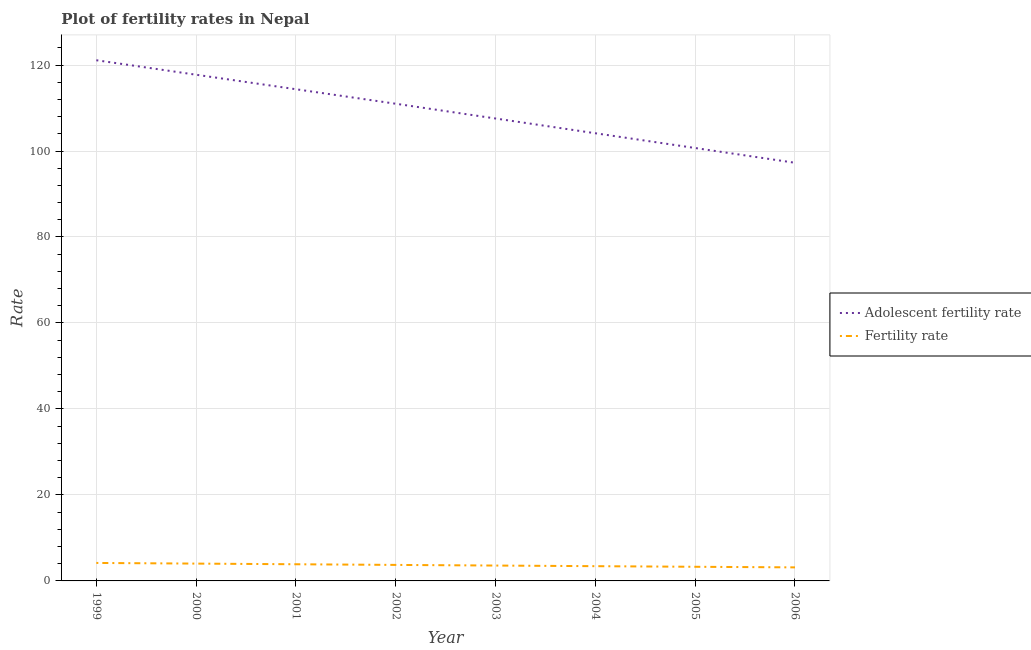How many different coloured lines are there?
Your response must be concise. 2. Is the number of lines equal to the number of legend labels?
Make the answer very short. Yes. What is the adolescent fertility rate in 2000?
Provide a succinct answer. 117.74. Across all years, what is the maximum fertility rate?
Provide a succinct answer. 4.18. Across all years, what is the minimum fertility rate?
Your answer should be very brief. 3.15. What is the total adolescent fertility rate in the graph?
Your response must be concise. 873.88. What is the difference between the fertility rate in 2002 and that in 2006?
Offer a very short reply. 0.57. What is the difference between the fertility rate in 2003 and the adolescent fertility rate in 2006?
Your answer should be very brief. -93.69. What is the average fertility rate per year?
Provide a short and direct response. 3.66. In the year 2001, what is the difference between the adolescent fertility rate and fertility rate?
Give a very brief answer. 110.49. What is the ratio of the adolescent fertility rate in 2003 to that in 2004?
Provide a succinct answer. 1.03. Is the difference between the adolescent fertility rate in 1999 and 2006 greater than the difference between the fertility rate in 1999 and 2006?
Give a very brief answer. Yes. What is the difference between the highest and the second highest adolescent fertility rate?
Offer a very short reply. 3.37. What is the difference between the highest and the lowest adolescent fertility rate?
Keep it short and to the point. 23.85. In how many years, is the adolescent fertility rate greater than the average adolescent fertility rate taken over all years?
Provide a short and direct response. 4. Is the sum of the fertility rate in 2002 and 2005 greater than the maximum adolescent fertility rate across all years?
Your answer should be compact. No. How many lines are there?
Your answer should be very brief. 2. Does the graph contain grids?
Your answer should be very brief. Yes. How many legend labels are there?
Provide a short and direct response. 2. What is the title of the graph?
Provide a succinct answer. Plot of fertility rates in Nepal. What is the label or title of the Y-axis?
Provide a short and direct response. Rate. What is the Rate of Adolescent fertility rate in 1999?
Offer a very short reply. 121.12. What is the Rate in Fertility rate in 1999?
Your answer should be very brief. 4.18. What is the Rate of Adolescent fertility rate in 2000?
Keep it short and to the point. 117.74. What is the Rate of Fertility rate in 2000?
Give a very brief answer. 4.03. What is the Rate of Adolescent fertility rate in 2001?
Ensure brevity in your answer.  114.37. What is the Rate of Fertility rate in 2001?
Offer a very short reply. 3.88. What is the Rate in Adolescent fertility rate in 2002?
Your answer should be very brief. 111. What is the Rate in Fertility rate in 2002?
Your answer should be compact. 3.72. What is the Rate of Adolescent fertility rate in 2003?
Ensure brevity in your answer.  107.56. What is the Rate in Fertility rate in 2003?
Ensure brevity in your answer.  3.58. What is the Rate of Adolescent fertility rate in 2004?
Provide a short and direct response. 104.13. What is the Rate in Fertility rate in 2004?
Offer a terse response. 3.43. What is the Rate in Adolescent fertility rate in 2005?
Provide a short and direct response. 100.7. What is the Rate in Fertility rate in 2005?
Your response must be concise. 3.29. What is the Rate of Adolescent fertility rate in 2006?
Offer a terse response. 97.26. What is the Rate in Fertility rate in 2006?
Offer a terse response. 3.15. Across all years, what is the maximum Rate in Adolescent fertility rate?
Offer a terse response. 121.12. Across all years, what is the maximum Rate of Fertility rate?
Give a very brief answer. 4.18. Across all years, what is the minimum Rate of Adolescent fertility rate?
Ensure brevity in your answer.  97.26. Across all years, what is the minimum Rate of Fertility rate?
Keep it short and to the point. 3.15. What is the total Rate of Adolescent fertility rate in the graph?
Give a very brief answer. 873.88. What is the total Rate in Fertility rate in the graph?
Keep it short and to the point. 29.26. What is the difference between the Rate of Adolescent fertility rate in 1999 and that in 2000?
Offer a terse response. 3.37. What is the difference between the Rate of Fertility rate in 1999 and that in 2000?
Make the answer very short. 0.15. What is the difference between the Rate in Adolescent fertility rate in 1999 and that in 2001?
Make the answer very short. 6.75. What is the difference between the Rate in Fertility rate in 1999 and that in 2001?
Your answer should be compact. 0.3. What is the difference between the Rate of Adolescent fertility rate in 1999 and that in 2002?
Provide a short and direct response. 10.12. What is the difference between the Rate of Fertility rate in 1999 and that in 2002?
Keep it short and to the point. 0.46. What is the difference between the Rate in Adolescent fertility rate in 1999 and that in 2003?
Your response must be concise. 13.55. What is the difference between the Rate of Fertility rate in 1999 and that in 2003?
Offer a very short reply. 0.61. What is the difference between the Rate of Adolescent fertility rate in 1999 and that in 2004?
Ensure brevity in your answer.  16.99. What is the difference between the Rate of Fertility rate in 1999 and that in 2004?
Keep it short and to the point. 0.75. What is the difference between the Rate of Adolescent fertility rate in 1999 and that in 2005?
Your answer should be compact. 20.42. What is the difference between the Rate of Fertility rate in 1999 and that in 2005?
Give a very brief answer. 0.89. What is the difference between the Rate of Adolescent fertility rate in 1999 and that in 2006?
Keep it short and to the point. 23.85. What is the difference between the Rate of Fertility rate in 1999 and that in 2006?
Provide a succinct answer. 1.03. What is the difference between the Rate in Adolescent fertility rate in 2000 and that in 2001?
Ensure brevity in your answer.  3.37. What is the difference between the Rate of Fertility rate in 2000 and that in 2001?
Ensure brevity in your answer.  0.15. What is the difference between the Rate in Adolescent fertility rate in 2000 and that in 2002?
Provide a short and direct response. 6.75. What is the difference between the Rate of Fertility rate in 2000 and that in 2002?
Offer a terse response. 0.31. What is the difference between the Rate of Adolescent fertility rate in 2000 and that in 2003?
Keep it short and to the point. 10.18. What is the difference between the Rate in Fertility rate in 2000 and that in 2003?
Provide a short and direct response. 0.46. What is the difference between the Rate of Adolescent fertility rate in 2000 and that in 2004?
Your answer should be compact. 13.61. What is the difference between the Rate of Adolescent fertility rate in 2000 and that in 2005?
Your answer should be very brief. 17.05. What is the difference between the Rate of Fertility rate in 2000 and that in 2005?
Keep it short and to the point. 0.74. What is the difference between the Rate in Adolescent fertility rate in 2000 and that in 2006?
Your response must be concise. 20.48. What is the difference between the Rate in Fertility rate in 2000 and that in 2006?
Provide a succinct answer. 0.88. What is the difference between the Rate of Adolescent fertility rate in 2001 and that in 2002?
Provide a succinct answer. 3.37. What is the difference between the Rate in Fertility rate in 2001 and that in 2002?
Provide a succinct answer. 0.15. What is the difference between the Rate of Adolescent fertility rate in 2001 and that in 2003?
Offer a terse response. 6.81. What is the difference between the Rate in Fertility rate in 2001 and that in 2003?
Keep it short and to the point. 0.3. What is the difference between the Rate in Adolescent fertility rate in 2001 and that in 2004?
Your answer should be very brief. 10.24. What is the difference between the Rate in Fertility rate in 2001 and that in 2004?
Offer a terse response. 0.45. What is the difference between the Rate in Adolescent fertility rate in 2001 and that in 2005?
Provide a succinct answer. 13.67. What is the difference between the Rate of Fertility rate in 2001 and that in 2005?
Your answer should be compact. 0.59. What is the difference between the Rate of Adolescent fertility rate in 2001 and that in 2006?
Give a very brief answer. 17.1. What is the difference between the Rate in Fertility rate in 2001 and that in 2006?
Your answer should be very brief. 0.73. What is the difference between the Rate in Adolescent fertility rate in 2002 and that in 2003?
Your answer should be compact. 3.43. What is the difference between the Rate in Fertility rate in 2002 and that in 2003?
Ensure brevity in your answer.  0.15. What is the difference between the Rate in Adolescent fertility rate in 2002 and that in 2004?
Keep it short and to the point. 6.87. What is the difference between the Rate in Fertility rate in 2002 and that in 2004?
Provide a short and direct response. 0.29. What is the difference between the Rate in Adolescent fertility rate in 2002 and that in 2005?
Keep it short and to the point. 10.3. What is the difference between the Rate of Fertility rate in 2002 and that in 2005?
Ensure brevity in your answer.  0.43. What is the difference between the Rate of Adolescent fertility rate in 2002 and that in 2006?
Your answer should be very brief. 13.73. What is the difference between the Rate in Fertility rate in 2002 and that in 2006?
Your answer should be compact. 0.57. What is the difference between the Rate in Adolescent fertility rate in 2003 and that in 2004?
Keep it short and to the point. 3.43. What is the difference between the Rate in Fertility rate in 2003 and that in 2004?
Provide a succinct answer. 0.14. What is the difference between the Rate of Adolescent fertility rate in 2003 and that in 2005?
Provide a short and direct response. 6.87. What is the difference between the Rate in Fertility rate in 2003 and that in 2005?
Offer a very short reply. 0.29. What is the difference between the Rate in Adolescent fertility rate in 2003 and that in 2006?
Your answer should be very brief. 10.3. What is the difference between the Rate in Fertility rate in 2003 and that in 2006?
Make the answer very short. 0.42. What is the difference between the Rate of Adolescent fertility rate in 2004 and that in 2005?
Offer a very short reply. 3.43. What is the difference between the Rate of Fertility rate in 2004 and that in 2005?
Offer a terse response. 0.14. What is the difference between the Rate of Adolescent fertility rate in 2004 and that in 2006?
Offer a very short reply. 6.87. What is the difference between the Rate of Fertility rate in 2004 and that in 2006?
Provide a short and direct response. 0.28. What is the difference between the Rate in Adolescent fertility rate in 2005 and that in 2006?
Offer a terse response. 3.43. What is the difference between the Rate in Fertility rate in 2005 and that in 2006?
Make the answer very short. 0.14. What is the difference between the Rate of Adolescent fertility rate in 1999 and the Rate of Fertility rate in 2000?
Keep it short and to the point. 117.09. What is the difference between the Rate of Adolescent fertility rate in 1999 and the Rate of Fertility rate in 2001?
Provide a succinct answer. 117.24. What is the difference between the Rate of Adolescent fertility rate in 1999 and the Rate of Fertility rate in 2002?
Make the answer very short. 117.39. What is the difference between the Rate of Adolescent fertility rate in 1999 and the Rate of Fertility rate in 2003?
Keep it short and to the point. 117.54. What is the difference between the Rate of Adolescent fertility rate in 1999 and the Rate of Fertility rate in 2004?
Offer a terse response. 117.69. What is the difference between the Rate in Adolescent fertility rate in 1999 and the Rate in Fertility rate in 2005?
Make the answer very short. 117.83. What is the difference between the Rate in Adolescent fertility rate in 1999 and the Rate in Fertility rate in 2006?
Provide a succinct answer. 117.97. What is the difference between the Rate in Adolescent fertility rate in 2000 and the Rate in Fertility rate in 2001?
Provide a succinct answer. 113.87. What is the difference between the Rate in Adolescent fertility rate in 2000 and the Rate in Fertility rate in 2002?
Give a very brief answer. 114.02. What is the difference between the Rate in Adolescent fertility rate in 2000 and the Rate in Fertility rate in 2003?
Ensure brevity in your answer.  114.17. What is the difference between the Rate of Adolescent fertility rate in 2000 and the Rate of Fertility rate in 2004?
Make the answer very short. 114.31. What is the difference between the Rate of Adolescent fertility rate in 2000 and the Rate of Fertility rate in 2005?
Ensure brevity in your answer.  114.45. What is the difference between the Rate in Adolescent fertility rate in 2000 and the Rate in Fertility rate in 2006?
Provide a succinct answer. 114.59. What is the difference between the Rate in Adolescent fertility rate in 2001 and the Rate in Fertility rate in 2002?
Your answer should be compact. 110.65. What is the difference between the Rate in Adolescent fertility rate in 2001 and the Rate in Fertility rate in 2003?
Offer a very short reply. 110.79. What is the difference between the Rate in Adolescent fertility rate in 2001 and the Rate in Fertility rate in 2004?
Keep it short and to the point. 110.94. What is the difference between the Rate of Adolescent fertility rate in 2001 and the Rate of Fertility rate in 2005?
Offer a terse response. 111.08. What is the difference between the Rate in Adolescent fertility rate in 2001 and the Rate in Fertility rate in 2006?
Give a very brief answer. 111.22. What is the difference between the Rate of Adolescent fertility rate in 2002 and the Rate of Fertility rate in 2003?
Keep it short and to the point. 107.42. What is the difference between the Rate of Adolescent fertility rate in 2002 and the Rate of Fertility rate in 2004?
Give a very brief answer. 107.57. What is the difference between the Rate of Adolescent fertility rate in 2002 and the Rate of Fertility rate in 2005?
Ensure brevity in your answer.  107.71. What is the difference between the Rate in Adolescent fertility rate in 2002 and the Rate in Fertility rate in 2006?
Your response must be concise. 107.84. What is the difference between the Rate of Adolescent fertility rate in 2003 and the Rate of Fertility rate in 2004?
Provide a short and direct response. 104.13. What is the difference between the Rate of Adolescent fertility rate in 2003 and the Rate of Fertility rate in 2005?
Your answer should be very brief. 104.27. What is the difference between the Rate in Adolescent fertility rate in 2003 and the Rate in Fertility rate in 2006?
Your answer should be compact. 104.41. What is the difference between the Rate of Adolescent fertility rate in 2004 and the Rate of Fertility rate in 2005?
Give a very brief answer. 100.84. What is the difference between the Rate in Adolescent fertility rate in 2004 and the Rate in Fertility rate in 2006?
Give a very brief answer. 100.98. What is the difference between the Rate of Adolescent fertility rate in 2005 and the Rate of Fertility rate in 2006?
Your response must be concise. 97.55. What is the average Rate in Adolescent fertility rate per year?
Give a very brief answer. 109.23. What is the average Rate of Fertility rate per year?
Provide a short and direct response. 3.66. In the year 1999, what is the difference between the Rate in Adolescent fertility rate and Rate in Fertility rate?
Your answer should be compact. 116.93. In the year 2000, what is the difference between the Rate of Adolescent fertility rate and Rate of Fertility rate?
Provide a short and direct response. 113.71. In the year 2001, what is the difference between the Rate of Adolescent fertility rate and Rate of Fertility rate?
Offer a terse response. 110.49. In the year 2002, what is the difference between the Rate in Adolescent fertility rate and Rate in Fertility rate?
Offer a terse response. 107.27. In the year 2003, what is the difference between the Rate in Adolescent fertility rate and Rate in Fertility rate?
Provide a short and direct response. 103.99. In the year 2004, what is the difference between the Rate in Adolescent fertility rate and Rate in Fertility rate?
Your answer should be compact. 100.7. In the year 2005, what is the difference between the Rate in Adolescent fertility rate and Rate in Fertility rate?
Ensure brevity in your answer.  97.41. In the year 2006, what is the difference between the Rate of Adolescent fertility rate and Rate of Fertility rate?
Provide a short and direct response. 94.11. What is the ratio of the Rate of Adolescent fertility rate in 1999 to that in 2000?
Make the answer very short. 1.03. What is the ratio of the Rate in Fertility rate in 1999 to that in 2000?
Your answer should be compact. 1.04. What is the ratio of the Rate in Adolescent fertility rate in 1999 to that in 2001?
Give a very brief answer. 1.06. What is the ratio of the Rate of Fertility rate in 1999 to that in 2001?
Your answer should be very brief. 1.08. What is the ratio of the Rate of Adolescent fertility rate in 1999 to that in 2002?
Keep it short and to the point. 1.09. What is the ratio of the Rate in Fertility rate in 1999 to that in 2002?
Make the answer very short. 1.12. What is the ratio of the Rate in Adolescent fertility rate in 1999 to that in 2003?
Your response must be concise. 1.13. What is the ratio of the Rate in Fertility rate in 1999 to that in 2003?
Make the answer very short. 1.17. What is the ratio of the Rate of Adolescent fertility rate in 1999 to that in 2004?
Provide a succinct answer. 1.16. What is the ratio of the Rate of Fertility rate in 1999 to that in 2004?
Your answer should be very brief. 1.22. What is the ratio of the Rate of Adolescent fertility rate in 1999 to that in 2005?
Offer a very short reply. 1.2. What is the ratio of the Rate in Fertility rate in 1999 to that in 2005?
Keep it short and to the point. 1.27. What is the ratio of the Rate in Adolescent fertility rate in 1999 to that in 2006?
Provide a succinct answer. 1.25. What is the ratio of the Rate in Fertility rate in 1999 to that in 2006?
Provide a succinct answer. 1.33. What is the ratio of the Rate of Adolescent fertility rate in 2000 to that in 2001?
Offer a terse response. 1.03. What is the ratio of the Rate in Fertility rate in 2000 to that in 2001?
Ensure brevity in your answer.  1.04. What is the ratio of the Rate in Adolescent fertility rate in 2000 to that in 2002?
Give a very brief answer. 1.06. What is the ratio of the Rate of Fertility rate in 2000 to that in 2002?
Provide a short and direct response. 1.08. What is the ratio of the Rate of Adolescent fertility rate in 2000 to that in 2003?
Provide a short and direct response. 1.09. What is the ratio of the Rate in Fertility rate in 2000 to that in 2003?
Provide a succinct answer. 1.13. What is the ratio of the Rate of Adolescent fertility rate in 2000 to that in 2004?
Your response must be concise. 1.13. What is the ratio of the Rate in Fertility rate in 2000 to that in 2004?
Your response must be concise. 1.17. What is the ratio of the Rate in Adolescent fertility rate in 2000 to that in 2005?
Provide a succinct answer. 1.17. What is the ratio of the Rate in Fertility rate in 2000 to that in 2005?
Give a very brief answer. 1.23. What is the ratio of the Rate of Adolescent fertility rate in 2000 to that in 2006?
Ensure brevity in your answer.  1.21. What is the ratio of the Rate of Fertility rate in 2000 to that in 2006?
Make the answer very short. 1.28. What is the ratio of the Rate of Adolescent fertility rate in 2001 to that in 2002?
Your answer should be very brief. 1.03. What is the ratio of the Rate in Fertility rate in 2001 to that in 2002?
Offer a terse response. 1.04. What is the ratio of the Rate in Adolescent fertility rate in 2001 to that in 2003?
Keep it short and to the point. 1.06. What is the ratio of the Rate in Fertility rate in 2001 to that in 2003?
Your answer should be compact. 1.08. What is the ratio of the Rate in Adolescent fertility rate in 2001 to that in 2004?
Provide a short and direct response. 1.1. What is the ratio of the Rate of Fertility rate in 2001 to that in 2004?
Your answer should be very brief. 1.13. What is the ratio of the Rate in Adolescent fertility rate in 2001 to that in 2005?
Give a very brief answer. 1.14. What is the ratio of the Rate of Fertility rate in 2001 to that in 2005?
Offer a very short reply. 1.18. What is the ratio of the Rate of Adolescent fertility rate in 2001 to that in 2006?
Offer a very short reply. 1.18. What is the ratio of the Rate in Fertility rate in 2001 to that in 2006?
Your answer should be compact. 1.23. What is the ratio of the Rate in Adolescent fertility rate in 2002 to that in 2003?
Ensure brevity in your answer.  1.03. What is the ratio of the Rate in Fertility rate in 2002 to that in 2003?
Your response must be concise. 1.04. What is the ratio of the Rate of Adolescent fertility rate in 2002 to that in 2004?
Keep it short and to the point. 1.07. What is the ratio of the Rate in Fertility rate in 2002 to that in 2004?
Your answer should be very brief. 1.09. What is the ratio of the Rate of Adolescent fertility rate in 2002 to that in 2005?
Provide a succinct answer. 1.1. What is the ratio of the Rate in Fertility rate in 2002 to that in 2005?
Your answer should be very brief. 1.13. What is the ratio of the Rate of Adolescent fertility rate in 2002 to that in 2006?
Provide a short and direct response. 1.14. What is the ratio of the Rate in Fertility rate in 2002 to that in 2006?
Offer a terse response. 1.18. What is the ratio of the Rate of Adolescent fertility rate in 2003 to that in 2004?
Make the answer very short. 1.03. What is the ratio of the Rate of Fertility rate in 2003 to that in 2004?
Your answer should be very brief. 1.04. What is the ratio of the Rate in Adolescent fertility rate in 2003 to that in 2005?
Your answer should be very brief. 1.07. What is the ratio of the Rate in Fertility rate in 2003 to that in 2005?
Provide a succinct answer. 1.09. What is the ratio of the Rate in Adolescent fertility rate in 2003 to that in 2006?
Offer a terse response. 1.11. What is the ratio of the Rate in Fertility rate in 2003 to that in 2006?
Keep it short and to the point. 1.13. What is the ratio of the Rate of Adolescent fertility rate in 2004 to that in 2005?
Provide a short and direct response. 1.03. What is the ratio of the Rate in Fertility rate in 2004 to that in 2005?
Offer a very short reply. 1.04. What is the ratio of the Rate in Adolescent fertility rate in 2004 to that in 2006?
Your answer should be compact. 1.07. What is the ratio of the Rate in Fertility rate in 2004 to that in 2006?
Your response must be concise. 1.09. What is the ratio of the Rate of Adolescent fertility rate in 2005 to that in 2006?
Give a very brief answer. 1.04. What is the ratio of the Rate of Fertility rate in 2005 to that in 2006?
Your answer should be compact. 1.04. What is the difference between the highest and the second highest Rate in Adolescent fertility rate?
Provide a short and direct response. 3.37. What is the difference between the highest and the second highest Rate in Fertility rate?
Provide a succinct answer. 0.15. What is the difference between the highest and the lowest Rate in Adolescent fertility rate?
Offer a terse response. 23.85. What is the difference between the highest and the lowest Rate of Fertility rate?
Offer a very short reply. 1.03. 